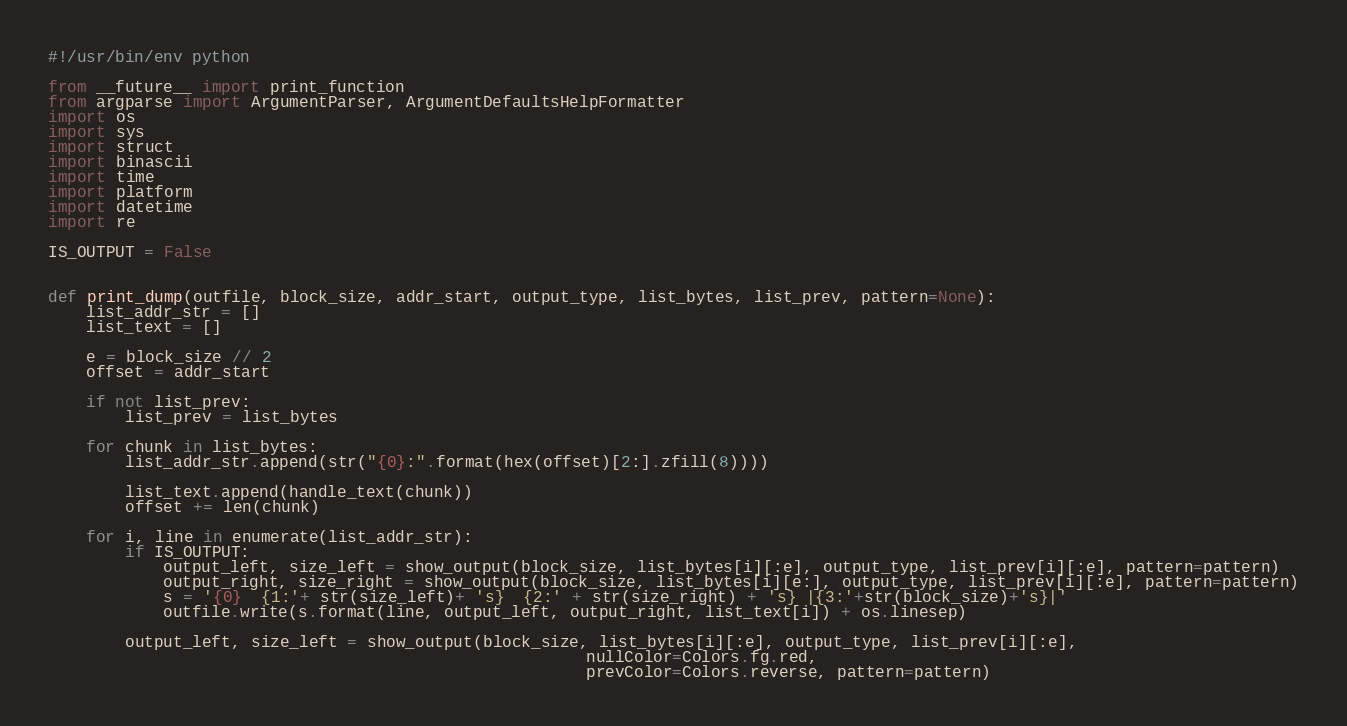<code> <loc_0><loc_0><loc_500><loc_500><_Python_>#!/usr/bin/env python

from __future__ import print_function
from argparse import ArgumentParser, ArgumentDefaultsHelpFormatter
import os
import sys
import struct
import binascii
import time
import platform
import datetime
import re

IS_OUTPUT = False


def print_dump(outfile, block_size, addr_start, output_type, list_bytes, list_prev, pattern=None):
    list_addr_str = []
    list_text = []

    e = block_size // 2
    offset = addr_start

    if not list_prev:
        list_prev = list_bytes

    for chunk in list_bytes:
        list_addr_str.append(str("{0}:".format(hex(offset)[2:].zfill(8))))

        list_text.append(handle_text(chunk))
        offset += len(chunk)

    for i, line in enumerate(list_addr_str):
        if IS_OUTPUT:
            output_left, size_left = show_output(block_size, list_bytes[i][:e], output_type, list_prev[i][:e], pattern=pattern)
            output_right, size_right = show_output(block_size, list_bytes[i][e:], output_type, list_prev[i][:e], pattern=pattern)
            s = '{0}  {1:'+ str(size_left)+ 's}  {2:' + str(size_right) + 's} |{3:'+str(block_size)+'s}|'
            outfile.write(s.format(line, output_left, output_right, list_text[i]) + os.linesep)

        output_left, size_left = show_output(block_size, list_bytes[i][:e], output_type, list_prev[i][:e],
                                                        nullColor=Colors.fg.red,
                                                        prevColor=Colors.reverse, pattern=pattern)</code> 